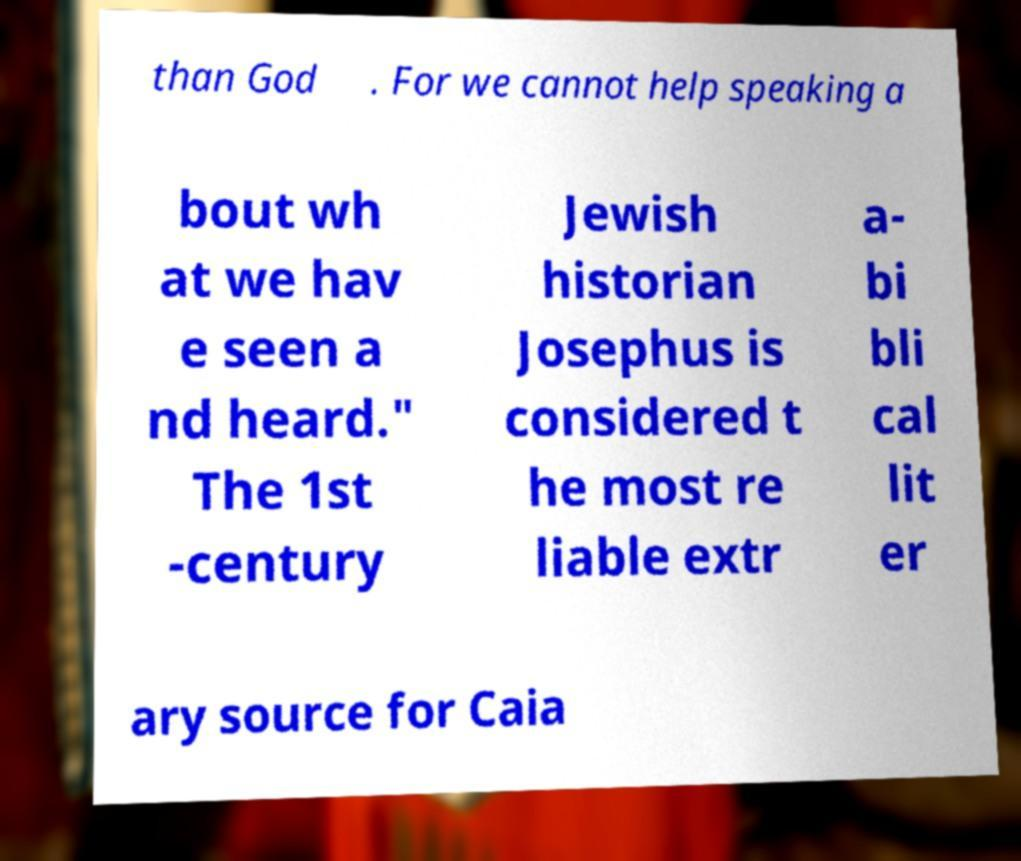I need the written content from this picture converted into text. Can you do that? than God . For we cannot help speaking a bout wh at we hav e seen a nd heard." The 1st -century Jewish historian Josephus is considered t he most re liable extr a- bi bli cal lit er ary source for Caia 